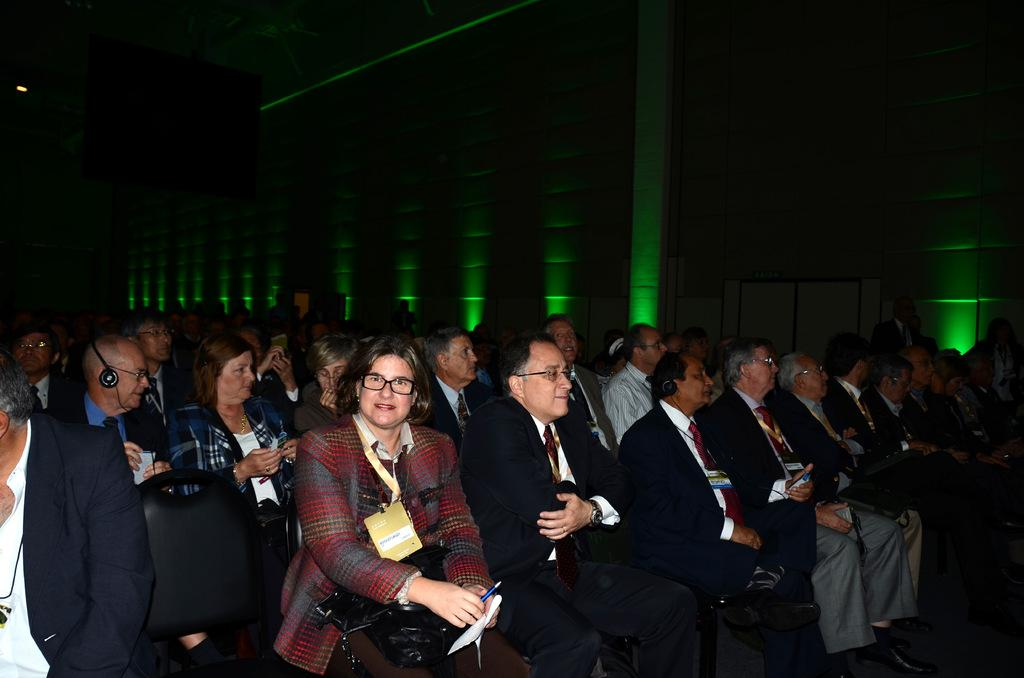Who is present in the image? There are people in the image. Where are the people located? The people are sitting in a theater. What can be seen on the wall in the image? There is a wall with green lights in the image. What type of structure is the people using to practice their humor in the image? There is no structure or practice of humor present in the image; it simply shows people sitting in a theater. 